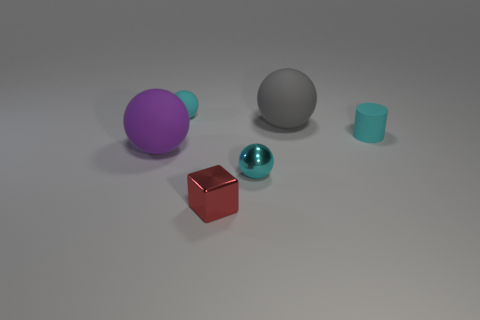Subtract all brown cubes. How many cyan balls are left? 2 Subtract all big purple rubber balls. How many balls are left? 3 Subtract all gray spheres. How many spheres are left? 3 Add 1 cyan things. How many objects exist? 7 Subtract all cylinders. How many objects are left? 5 Subtract 2 balls. How many balls are left? 2 Subtract 1 gray balls. How many objects are left? 5 Subtract all red spheres. Subtract all yellow cylinders. How many spheres are left? 4 Subtract all red cubes. Subtract all gray objects. How many objects are left? 4 Add 5 cyan metallic spheres. How many cyan metallic spheres are left? 6 